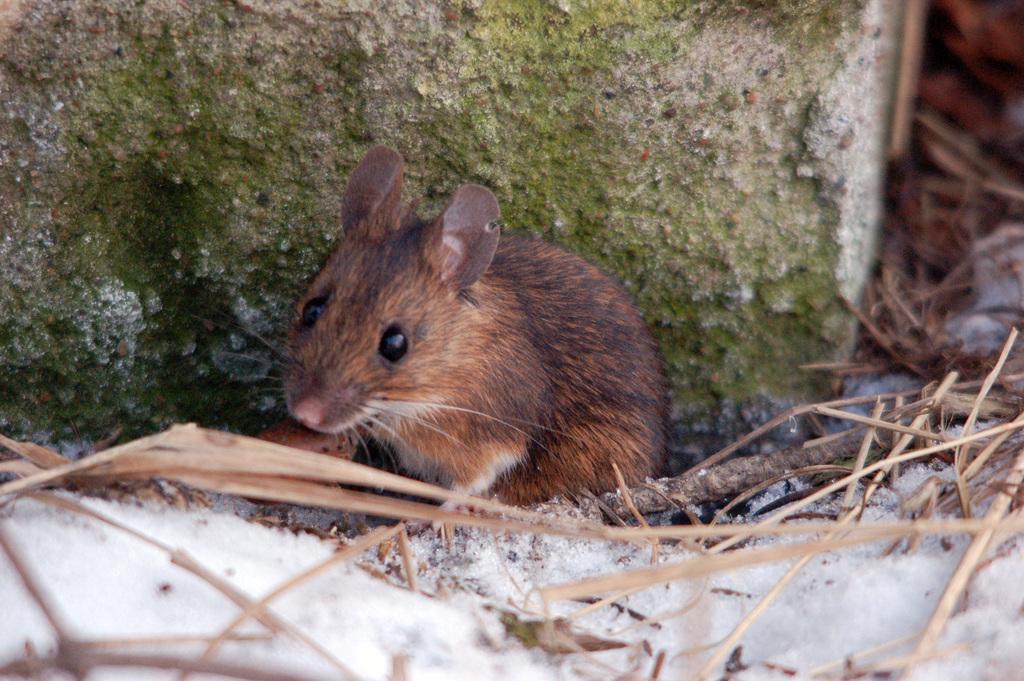How would you summarize this image in a sentence or two? In this image I can see a rat which is in brown color. In front I can see few sticks, background the wall is in green and cream color. 